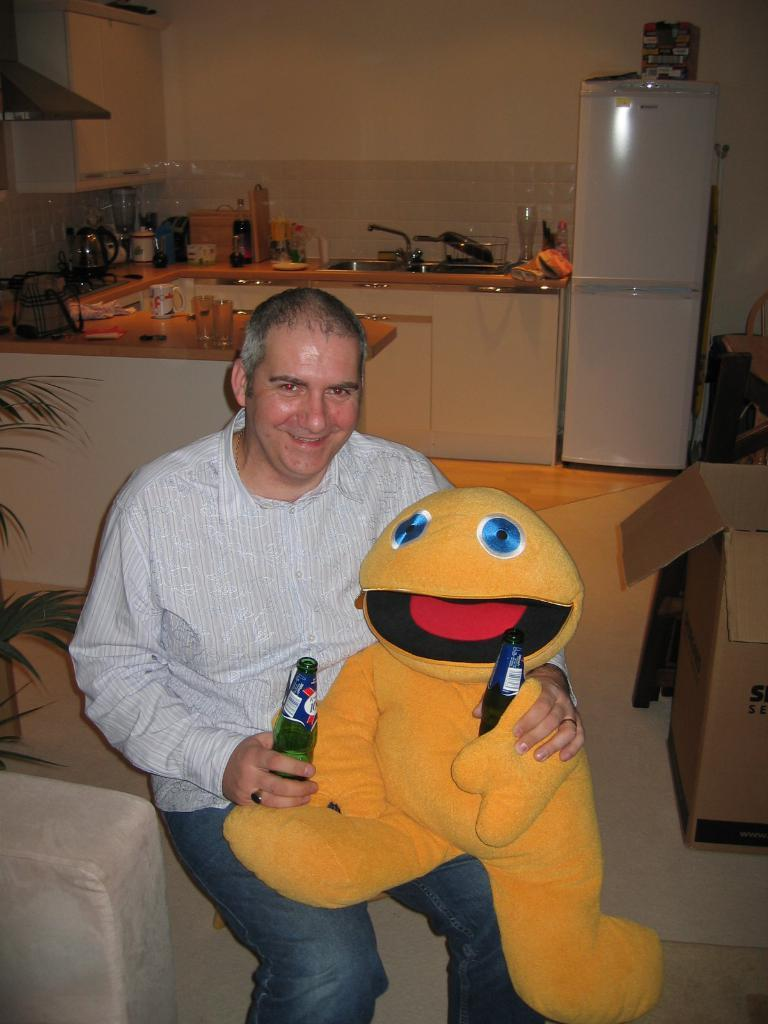Who is present in the image? There is a man in the image. What is the man holding? The man is holding a doll. What type of beverages can be seen in the image? There are cool drinks in the image. Where is the sofa located in the image? The sofa is on the left side of the image. What type of room can be seen in the background of the image? There is a kitchen in the background of the image. What appliance is visible in the kitchen? There is a fridge in the background of the image. What type of insect can be seen flying near the fridge in the image? There are no insects visible in the image, and therefore no such activity can be observed. 